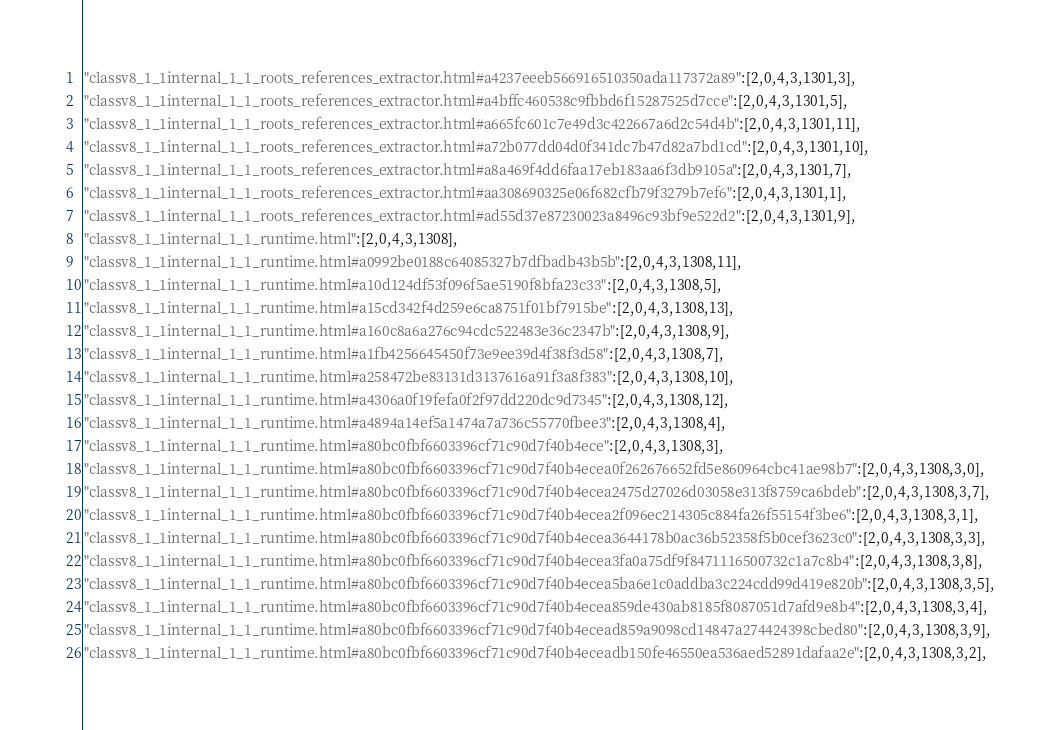<code> <loc_0><loc_0><loc_500><loc_500><_JavaScript_>"classv8_1_1internal_1_1_roots_references_extractor.html#a4237eeeb566916510350ada117372a89":[2,0,4,3,1301,3],
"classv8_1_1internal_1_1_roots_references_extractor.html#a4bffc460538c9fbbd6f15287525d7cce":[2,0,4,3,1301,5],
"classv8_1_1internal_1_1_roots_references_extractor.html#a665fc601c7e49d3c422667a6d2c54d4b":[2,0,4,3,1301,11],
"classv8_1_1internal_1_1_roots_references_extractor.html#a72b077dd04d0f341dc7b47d82a7bd1cd":[2,0,4,3,1301,10],
"classv8_1_1internal_1_1_roots_references_extractor.html#a8a469f4dd6faa17eb183aa6f3db9105a":[2,0,4,3,1301,7],
"classv8_1_1internal_1_1_roots_references_extractor.html#aa308690325e06f682cfb79f3279b7ef6":[2,0,4,3,1301,1],
"classv8_1_1internal_1_1_roots_references_extractor.html#ad55d37e87230023a8496c93bf9e522d2":[2,0,4,3,1301,9],
"classv8_1_1internal_1_1_runtime.html":[2,0,4,3,1308],
"classv8_1_1internal_1_1_runtime.html#a0992be0188c64085327b7dfbadb43b5b":[2,0,4,3,1308,11],
"classv8_1_1internal_1_1_runtime.html#a10d124df53f096f5ae5190f8bfa23c33":[2,0,4,3,1308,5],
"classv8_1_1internal_1_1_runtime.html#a15cd342f4d259e6ca8751f01bf7915be":[2,0,4,3,1308,13],
"classv8_1_1internal_1_1_runtime.html#a160c8a6a276c94cdc522483e36c2347b":[2,0,4,3,1308,9],
"classv8_1_1internal_1_1_runtime.html#a1fb4256645450f73e9ee39d4f38f3d58":[2,0,4,3,1308,7],
"classv8_1_1internal_1_1_runtime.html#a258472be83131d3137616a91f3a8f383":[2,0,4,3,1308,10],
"classv8_1_1internal_1_1_runtime.html#a4306a0f19fefa0f2f97dd220dc9d7345":[2,0,4,3,1308,12],
"classv8_1_1internal_1_1_runtime.html#a4894a14ef5a1474a7a736c55770fbee3":[2,0,4,3,1308,4],
"classv8_1_1internal_1_1_runtime.html#a80bc0fbf6603396cf71c90d7f40b4ece":[2,0,4,3,1308,3],
"classv8_1_1internal_1_1_runtime.html#a80bc0fbf6603396cf71c90d7f40b4ecea0f262676652fd5e860964cbc41ae98b7":[2,0,4,3,1308,3,0],
"classv8_1_1internal_1_1_runtime.html#a80bc0fbf6603396cf71c90d7f40b4ecea2475d27026d03058e313f8759ca6bdeb":[2,0,4,3,1308,3,7],
"classv8_1_1internal_1_1_runtime.html#a80bc0fbf6603396cf71c90d7f40b4ecea2f096ec214305c884fa26f55154f3be6":[2,0,4,3,1308,3,1],
"classv8_1_1internal_1_1_runtime.html#a80bc0fbf6603396cf71c90d7f40b4ecea3644178b0ac36b52358f5b0cef3623c0":[2,0,4,3,1308,3,3],
"classv8_1_1internal_1_1_runtime.html#a80bc0fbf6603396cf71c90d7f40b4ecea3fa0a75df9f8471116500732c1a7c8b4":[2,0,4,3,1308,3,8],
"classv8_1_1internal_1_1_runtime.html#a80bc0fbf6603396cf71c90d7f40b4ecea5ba6e1c0addba3c224cdd99d419e820b":[2,0,4,3,1308,3,5],
"classv8_1_1internal_1_1_runtime.html#a80bc0fbf6603396cf71c90d7f40b4ecea859de430ab8185f8087051d7afd9e8b4":[2,0,4,3,1308,3,4],
"classv8_1_1internal_1_1_runtime.html#a80bc0fbf6603396cf71c90d7f40b4ecead859a9098cd14847a274424398cbed80":[2,0,4,3,1308,3,9],
"classv8_1_1internal_1_1_runtime.html#a80bc0fbf6603396cf71c90d7f40b4eceadb150fe46550ea536aed52891dafaa2e":[2,0,4,3,1308,3,2],</code> 